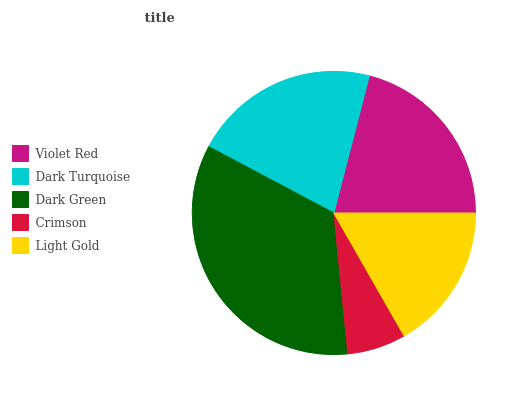Is Crimson the minimum?
Answer yes or no. Yes. Is Dark Green the maximum?
Answer yes or no. Yes. Is Dark Turquoise the minimum?
Answer yes or no. No. Is Dark Turquoise the maximum?
Answer yes or no. No. Is Dark Turquoise greater than Violet Red?
Answer yes or no. Yes. Is Violet Red less than Dark Turquoise?
Answer yes or no. Yes. Is Violet Red greater than Dark Turquoise?
Answer yes or no. No. Is Dark Turquoise less than Violet Red?
Answer yes or no. No. Is Violet Red the high median?
Answer yes or no. Yes. Is Violet Red the low median?
Answer yes or no. Yes. Is Light Gold the high median?
Answer yes or no. No. Is Light Gold the low median?
Answer yes or no. No. 